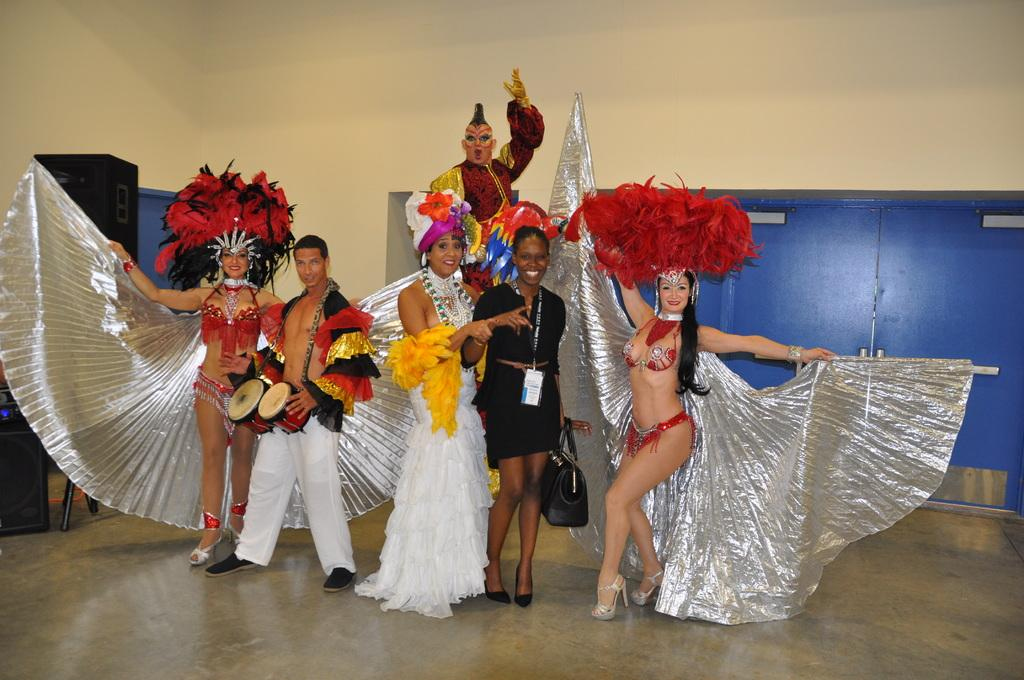What is happening in the image? There are people standing in the image. What are the people wearing? The people are wearing costumes. How do the people appear to be feeling? The people have smiles on their faces, indicating they are happy. What is one person holding in the image? One person is holding a musical instrument. What type of fuel is being used by the plants in the image? There are no plants present in the image, so there is no fuel being used by plants. 